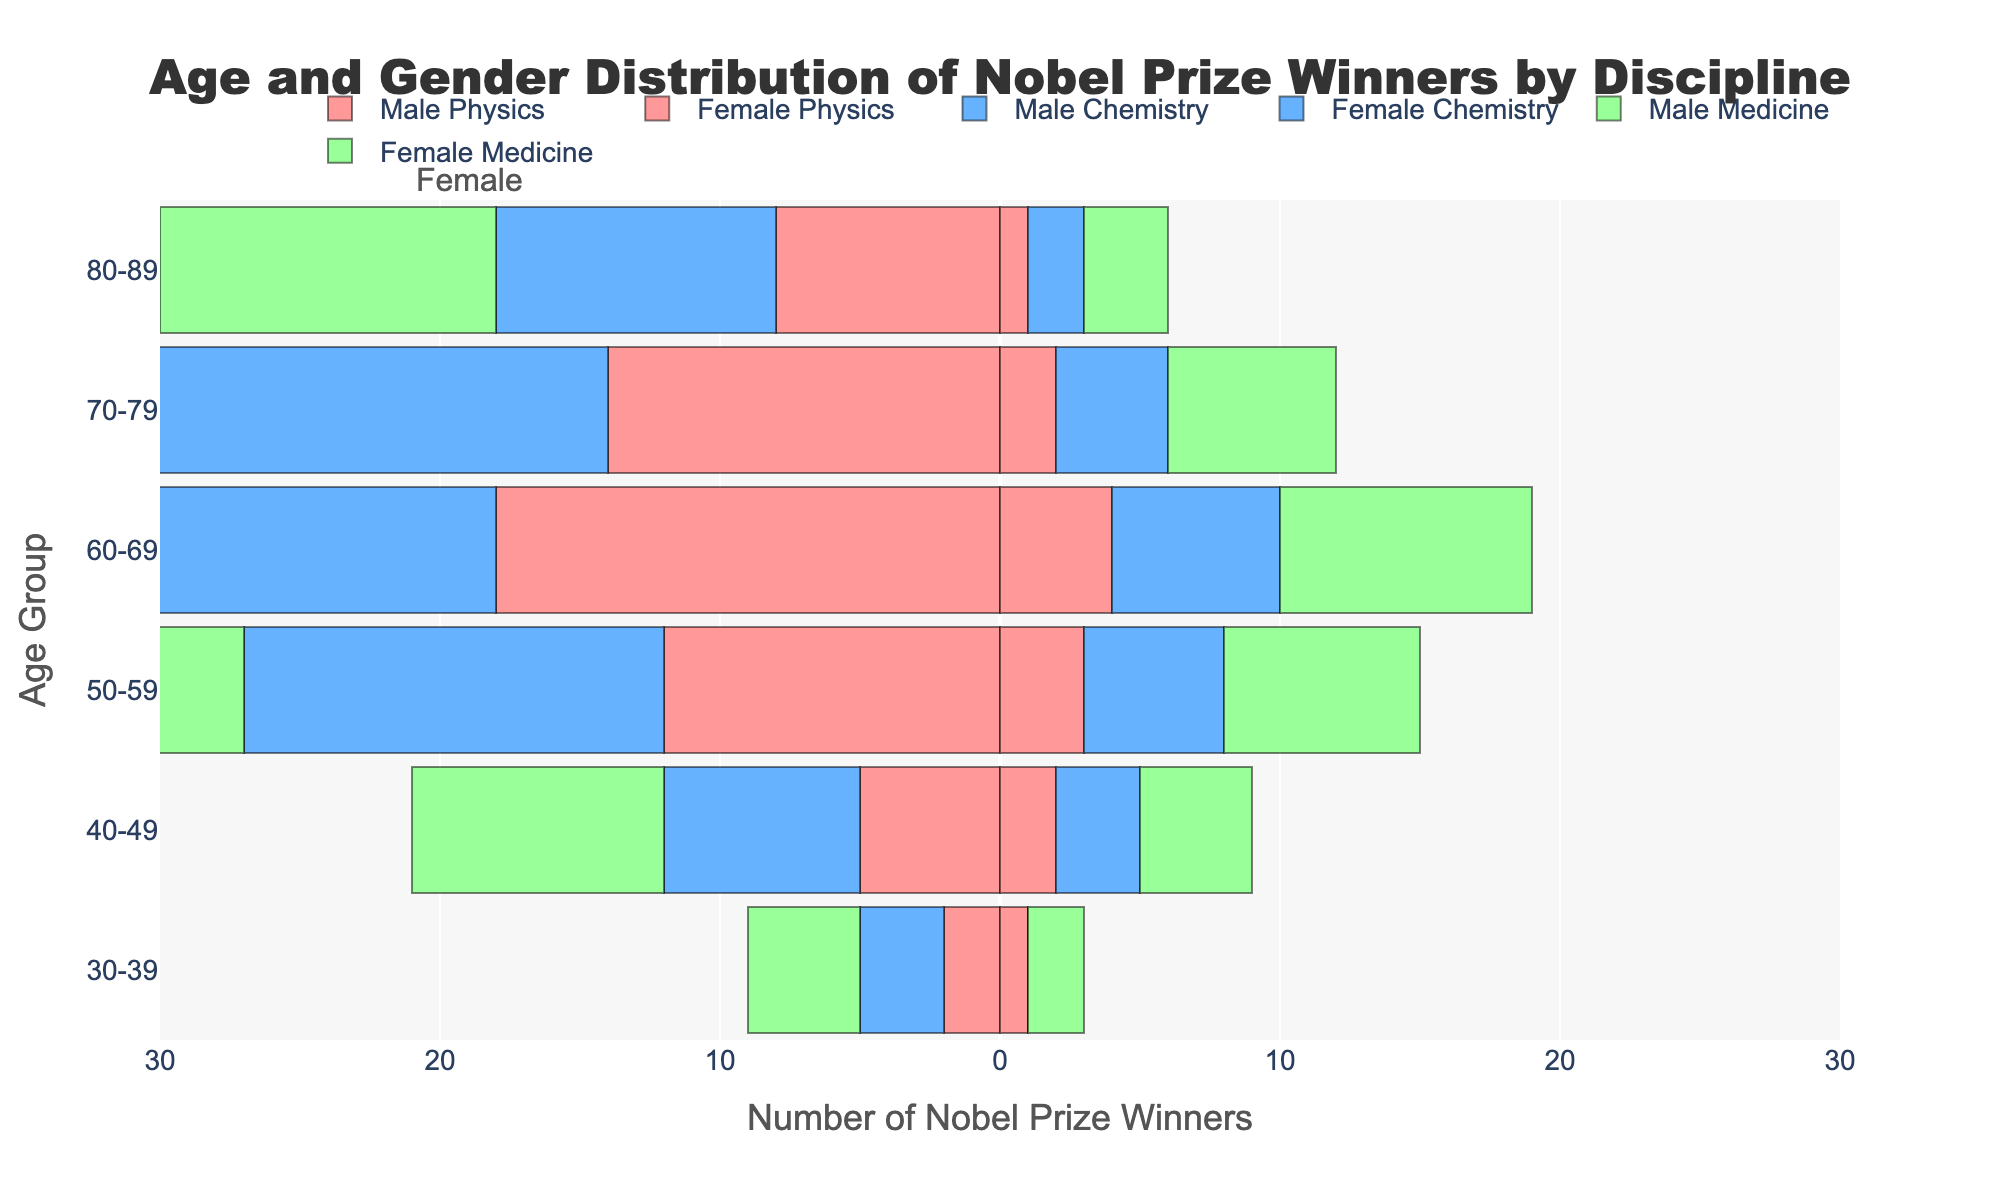What is the title of the plot? The title of the plot is shown at the top and is 'Age and Gender Distribution of Nobel Prize Winners by Discipline.'
Answer: Age and Gender Distribution of Nobel Prize Winners by Discipline What age group has the highest number of male Nobel Prize winners in Medicine? Looking at the bars for 'Male Medicine,' the age group 60-69 has the longest bar, indicating the highest number of winners.
Answer: 60-69 What is the total number of female Physics Nobel Prize winners across all age groups? Sum the values for female Physics across all age groups: 1+2+3+4+2+1=13.
Answer: 13 How does the number of male Chemistry Nobel Prize winners in the 50-59 age group compare to those in the 60-69 age group? The number of male Chemistry winners in the 50-59 age group is 15, and in the 60-69 age group is 22. Therefore, there are more winners in the 60-69 age group.
Answer: More in 60-69 What is the percentage of female Nobel Prize winners in the 70-79 age group in Physics, Chemistry, and Medicine combined? Sum the female winners for Physics, Chemistry, and Medicine in the 70-79 age group (2 + 4 + 6 = 12), then divide by the total number of winners (2 + 14 + 4 + 18 + 6 + 20 = 64). The percentage is (12/64) * 100 = 18.75%.
Answer: 18.75% Which discipline has the most even distribution of male and female Nobel Prize winners across all age groups? Examine each discipline's male and female totals: Physics: 59M, 13F; Chemistry: 75M, 20F; Medicine: 88M, 31F. Medicine has the closest male-to-female ratio.
Answer: Medicine What is the average number of male Nobel Prize winners in Chemistry across all age groups? Sum the values for male Chemistry across all age groups: (3+7+15+22+18+10 = 75); divide by the number of age groups (6). The average is 75/6 = 12.5.
Answer: 12.5 In which age group do we see the greatest disparity between male and female Nobel Prize winners in Medicine? Calculate the difference between male and female Medicine winners for each age group: 30-39: 4-2=2, 40-49: 9-4=5, 50-59: 18-7=11, 60-69: 25-9=16, 70-79: 20-6=14, 80-89: 12-3=9. The greatest disparity is in 60-69 with a difference of 16.
Answer: 60-69 For the 80-89 age group, which discipline has the fewest female Nobel Prize winners? Comparing the female winners across disciplines in the 80-89 age group, Physics has 1, Chemistry has 2, and Medicine has 3. Physics has the fewest.
Answer: Physics 